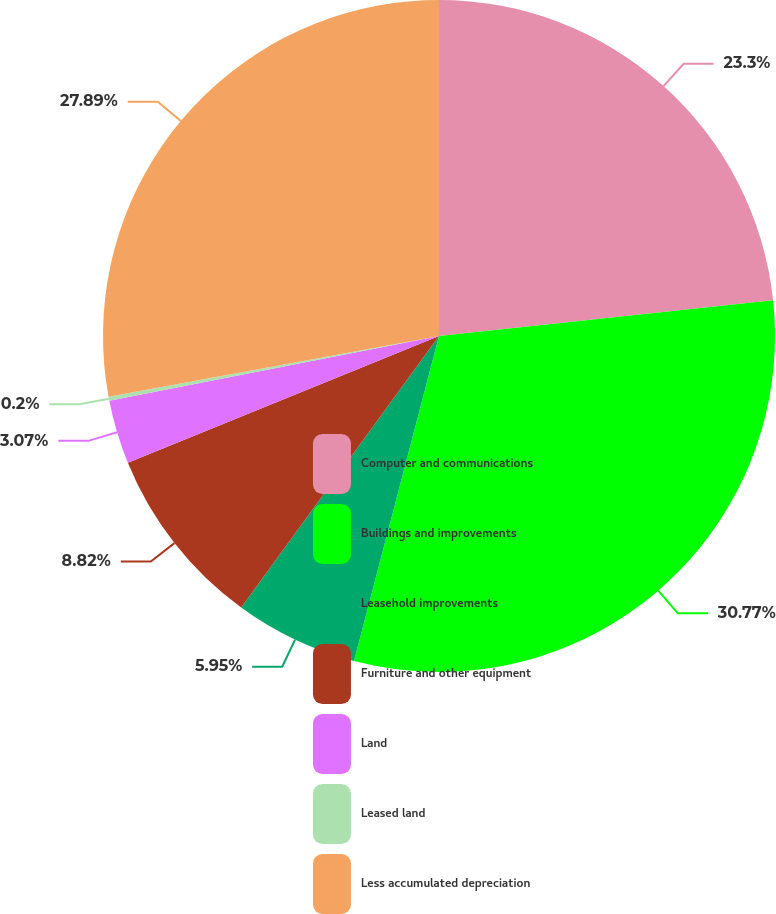Convert chart to OTSL. <chart><loc_0><loc_0><loc_500><loc_500><pie_chart><fcel>Computer and communications<fcel>Buildings and improvements<fcel>Leasehold improvements<fcel>Furniture and other equipment<fcel>Land<fcel>Leased land<fcel>Less accumulated depreciation<nl><fcel>23.3%<fcel>30.77%<fcel>5.95%<fcel>8.82%<fcel>3.07%<fcel>0.2%<fcel>27.89%<nl></chart> 